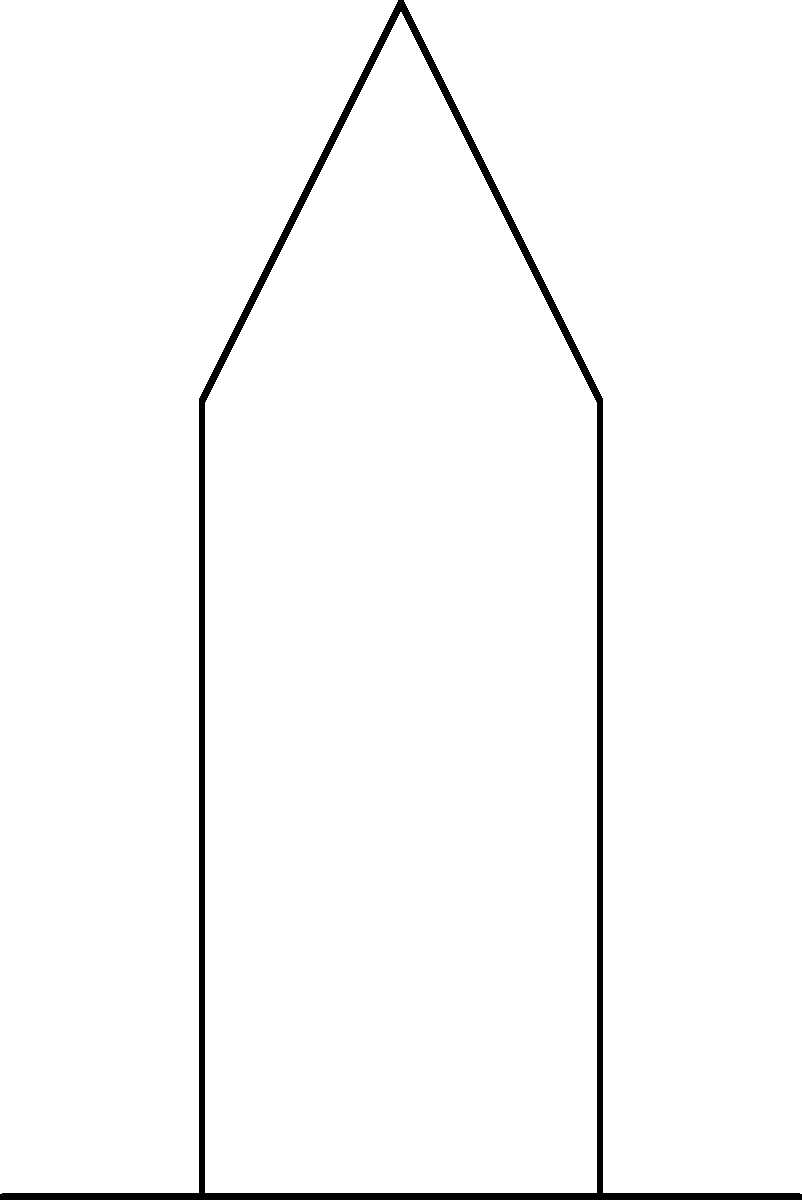As a software engineer who frequently attends church, you're developing an app to analyze posture during long services. Consider the forces acting on a person's spine while sitting in a church pew, as shown in the diagram. If the person's weight is 700 N and the backrest applies a horizontal force of 100 N, what is the magnitude of the normal force ($F_n$) exerted by the pew on the person? Let's approach this step-by-step:

1) First, we need to identify the forces acting on the person:
   - Gravitational force ($F_g$) acting downward
   - Normal force ($F_n$) from the pew acting upward
   - Backrest force ($F_b$) acting horizontally

2) We're given:
   - Weight (gravitational force) $F_g = 700$ N
   - Backrest force $F_b = 100$ N

3) In equilibrium, the sum of forces in each direction must be zero:
   - Vertical direction: $\sum F_y = 0$
   - Horizontal direction: $\sum F_x = 0$

4) For the vertical direction:
   $F_n - F_g = 0$
   $F_n = F_g = 700$ N

5) Note: The horizontal force from the backrest doesn't affect the normal force in this case, as it's perpendicular to the normal force.

Therefore, the magnitude of the normal force is equal to the person's weight.
Answer: 700 N 